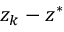Convert formula to latex. <formula><loc_0><loc_0><loc_500><loc_500>z _ { k } - z ^ { * }</formula> 